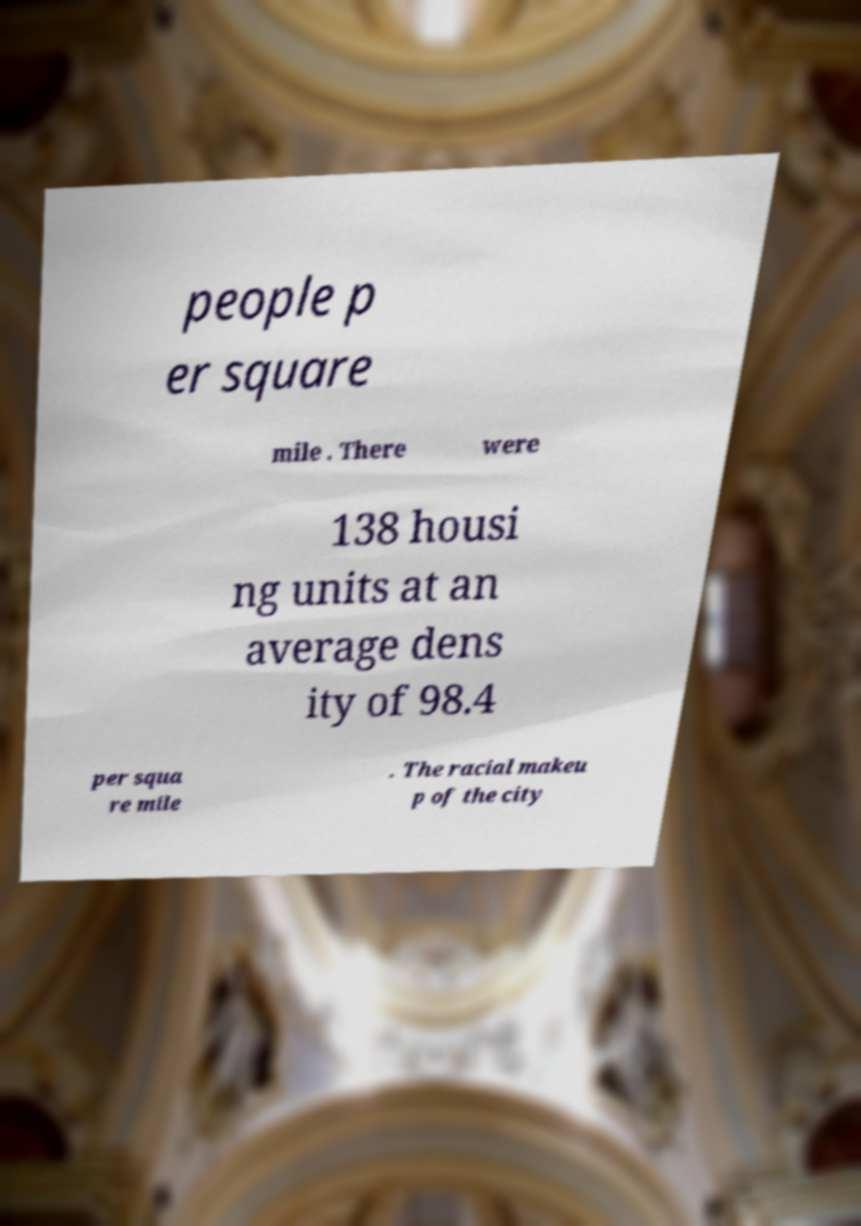Could you extract and type out the text from this image? people p er square mile . There were 138 housi ng units at an average dens ity of 98.4 per squa re mile . The racial makeu p of the city 